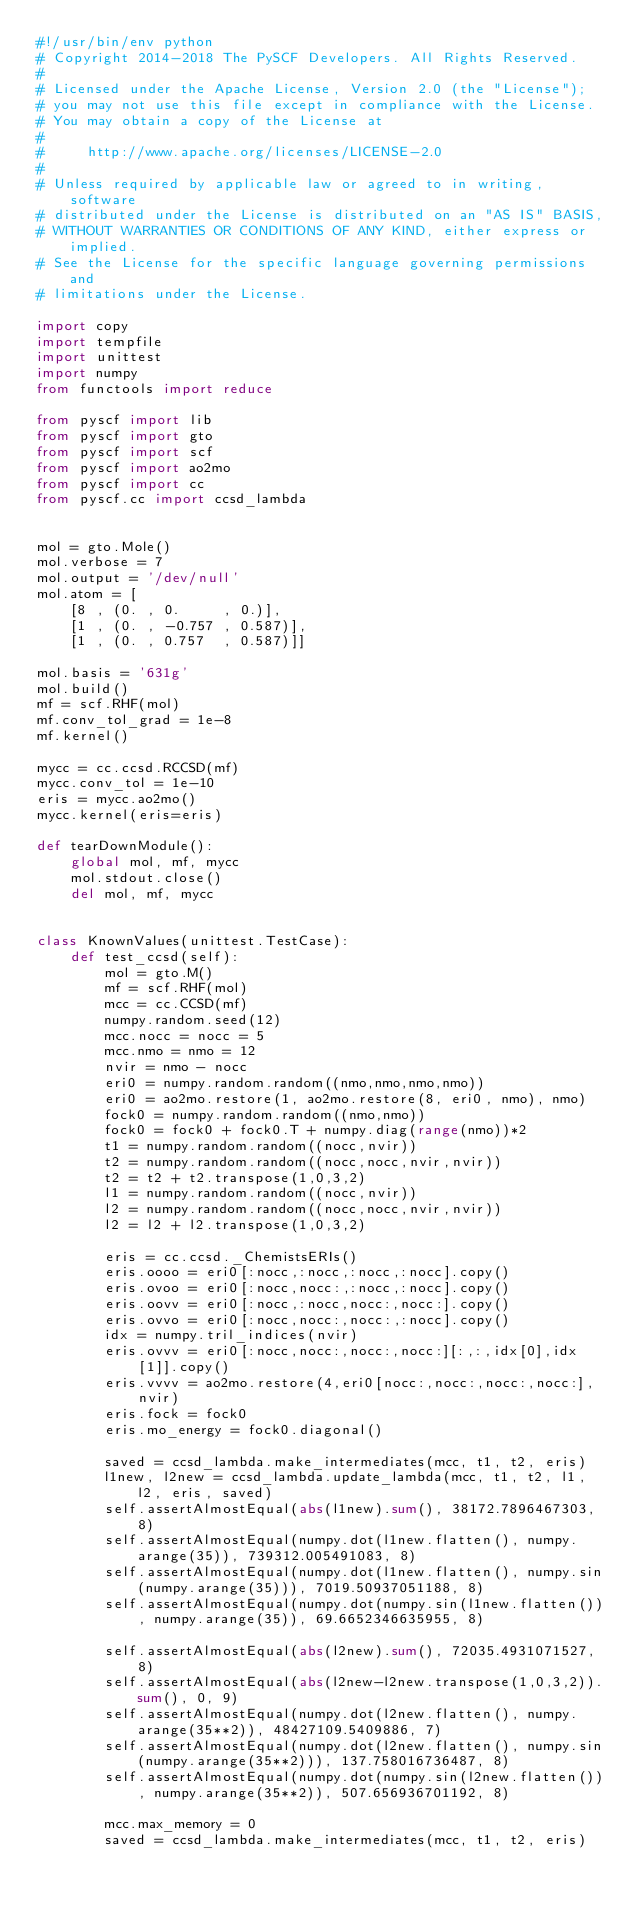<code> <loc_0><loc_0><loc_500><loc_500><_Python_>#!/usr/bin/env python
# Copyright 2014-2018 The PySCF Developers. All Rights Reserved.
#
# Licensed under the Apache License, Version 2.0 (the "License");
# you may not use this file except in compliance with the License.
# You may obtain a copy of the License at
#
#     http://www.apache.org/licenses/LICENSE-2.0
#
# Unless required by applicable law or agreed to in writing, software
# distributed under the License is distributed on an "AS IS" BASIS,
# WITHOUT WARRANTIES OR CONDITIONS OF ANY KIND, either express or implied.
# See the License for the specific language governing permissions and
# limitations under the License.

import copy
import tempfile
import unittest
import numpy
from functools import reduce

from pyscf import lib
from pyscf import gto
from pyscf import scf
from pyscf import ao2mo
from pyscf import cc
from pyscf.cc import ccsd_lambda


mol = gto.Mole()
mol.verbose = 7
mol.output = '/dev/null'
mol.atom = [
    [8 , (0. , 0.     , 0.)],
    [1 , (0. , -0.757 , 0.587)],
    [1 , (0. , 0.757  , 0.587)]]

mol.basis = '631g'
mol.build()
mf = scf.RHF(mol)
mf.conv_tol_grad = 1e-8
mf.kernel()

mycc = cc.ccsd.RCCSD(mf)
mycc.conv_tol = 1e-10
eris = mycc.ao2mo()
mycc.kernel(eris=eris)

def tearDownModule():
    global mol, mf, mycc
    mol.stdout.close()
    del mol, mf, mycc


class KnownValues(unittest.TestCase):
    def test_ccsd(self):
        mol = gto.M()
        mf = scf.RHF(mol)
        mcc = cc.CCSD(mf)
        numpy.random.seed(12)
        mcc.nocc = nocc = 5
        mcc.nmo = nmo = 12
        nvir = nmo - nocc
        eri0 = numpy.random.random((nmo,nmo,nmo,nmo))
        eri0 = ao2mo.restore(1, ao2mo.restore(8, eri0, nmo), nmo)
        fock0 = numpy.random.random((nmo,nmo))
        fock0 = fock0 + fock0.T + numpy.diag(range(nmo))*2
        t1 = numpy.random.random((nocc,nvir))
        t2 = numpy.random.random((nocc,nocc,nvir,nvir))
        t2 = t2 + t2.transpose(1,0,3,2)
        l1 = numpy.random.random((nocc,nvir))
        l2 = numpy.random.random((nocc,nocc,nvir,nvir))
        l2 = l2 + l2.transpose(1,0,3,2)

        eris = cc.ccsd._ChemistsERIs()
        eris.oooo = eri0[:nocc,:nocc,:nocc,:nocc].copy()
        eris.ovoo = eri0[:nocc,nocc:,:nocc,:nocc].copy()
        eris.oovv = eri0[:nocc,:nocc,nocc:,nocc:].copy()
        eris.ovvo = eri0[:nocc,nocc:,nocc:,:nocc].copy()
        idx = numpy.tril_indices(nvir)
        eris.ovvv = eri0[:nocc,nocc:,nocc:,nocc:][:,:,idx[0],idx[1]].copy()
        eris.vvvv = ao2mo.restore(4,eri0[nocc:,nocc:,nocc:,nocc:],nvir)
        eris.fock = fock0
        eris.mo_energy = fock0.diagonal()

        saved = ccsd_lambda.make_intermediates(mcc, t1, t2, eris)
        l1new, l2new = ccsd_lambda.update_lambda(mcc, t1, t2, l1, l2, eris, saved)
        self.assertAlmostEqual(abs(l1new).sum(), 38172.7896467303, 8)
        self.assertAlmostEqual(numpy.dot(l1new.flatten(), numpy.arange(35)), 739312.005491083, 8)
        self.assertAlmostEqual(numpy.dot(l1new.flatten(), numpy.sin(numpy.arange(35))), 7019.50937051188, 8)
        self.assertAlmostEqual(numpy.dot(numpy.sin(l1new.flatten()), numpy.arange(35)), 69.6652346635955, 8)

        self.assertAlmostEqual(abs(l2new).sum(), 72035.4931071527, 8)
        self.assertAlmostEqual(abs(l2new-l2new.transpose(1,0,3,2)).sum(), 0, 9)
        self.assertAlmostEqual(numpy.dot(l2new.flatten(), numpy.arange(35**2)), 48427109.5409886, 7)
        self.assertAlmostEqual(numpy.dot(l2new.flatten(), numpy.sin(numpy.arange(35**2))), 137.758016736487, 8)
        self.assertAlmostEqual(numpy.dot(numpy.sin(l2new.flatten()), numpy.arange(35**2)), 507.656936701192, 8)

        mcc.max_memory = 0
        saved = ccsd_lambda.make_intermediates(mcc, t1, t2, eris)</code> 